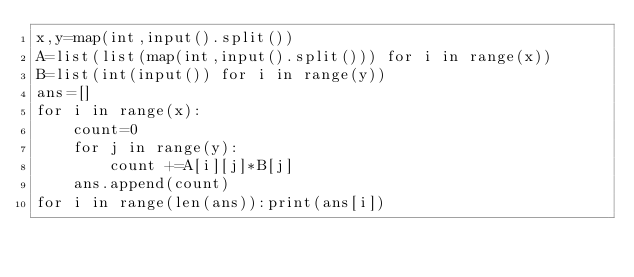Convert code to text. <code><loc_0><loc_0><loc_500><loc_500><_Python_>x,y=map(int,input().split())
A=list(list(map(int,input().split())) for i in range(x))
B=list(int(input()) for i in range(y))
ans=[]
for i in range(x):
    count=0
    for j in range(y):
        count +=A[i][j]*B[j]
    ans.append(count)
for i in range(len(ans)):print(ans[i])
</code> 